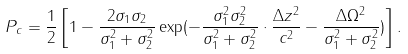Convert formula to latex. <formula><loc_0><loc_0><loc_500><loc_500>P _ { c } = \frac { 1 } { 2 } \left [ 1 - \frac { 2 \sigma _ { 1 } \sigma _ { 2 } } { \sigma _ { 1 } ^ { 2 } + \sigma _ { 2 } ^ { 2 } } \exp ( - \frac { \sigma _ { 1 } ^ { 2 } \sigma _ { 2 } ^ { 2 } } { \sigma _ { 1 } ^ { 2 } + \sigma _ { 2 } ^ { 2 } } \cdot \frac { \Delta z ^ { 2 } } { c ^ { 2 } } - \frac { \Delta \Omega ^ { 2 } } { \sigma _ { 1 } ^ { 2 } + \sigma _ { 2 } ^ { 2 } } ) \right ] .</formula> 